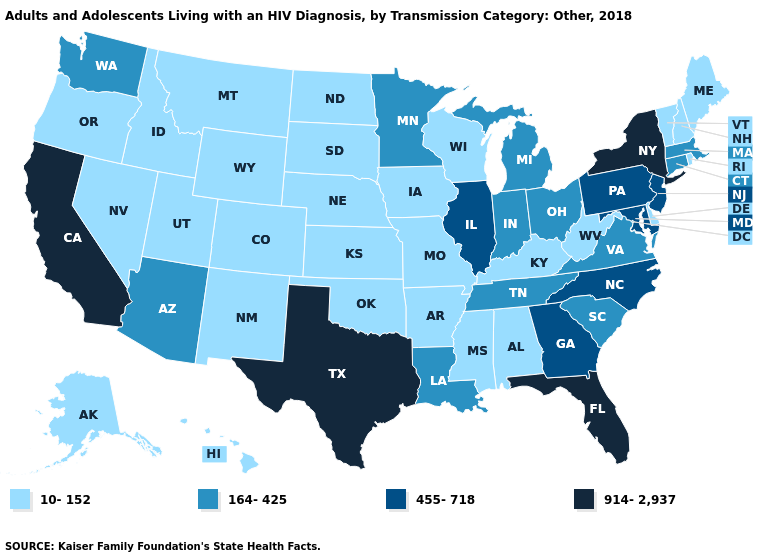Does Oklahoma have a higher value than Utah?
Keep it brief. No. What is the lowest value in the USA?
Write a very short answer. 10-152. What is the value of North Carolina?
Write a very short answer. 455-718. What is the value of Virginia?
Be succinct. 164-425. What is the value of Tennessee?
Write a very short answer. 164-425. Does the first symbol in the legend represent the smallest category?
Write a very short answer. Yes. Does the first symbol in the legend represent the smallest category?
Keep it brief. Yes. What is the value of Rhode Island?
Short answer required. 10-152. Which states have the lowest value in the USA?
Short answer required. Alabama, Alaska, Arkansas, Colorado, Delaware, Hawaii, Idaho, Iowa, Kansas, Kentucky, Maine, Mississippi, Missouri, Montana, Nebraska, Nevada, New Hampshire, New Mexico, North Dakota, Oklahoma, Oregon, Rhode Island, South Dakota, Utah, Vermont, West Virginia, Wisconsin, Wyoming. What is the value of Missouri?
Concise answer only. 10-152. Does North Carolina have a higher value than Maine?
Quick response, please. Yes. What is the highest value in the Northeast ?
Keep it brief. 914-2,937. What is the value of Massachusetts?
Quick response, please. 164-425. Which states have the highest value in the USA?
Short answer required. California, Florida, New York, Texas. 